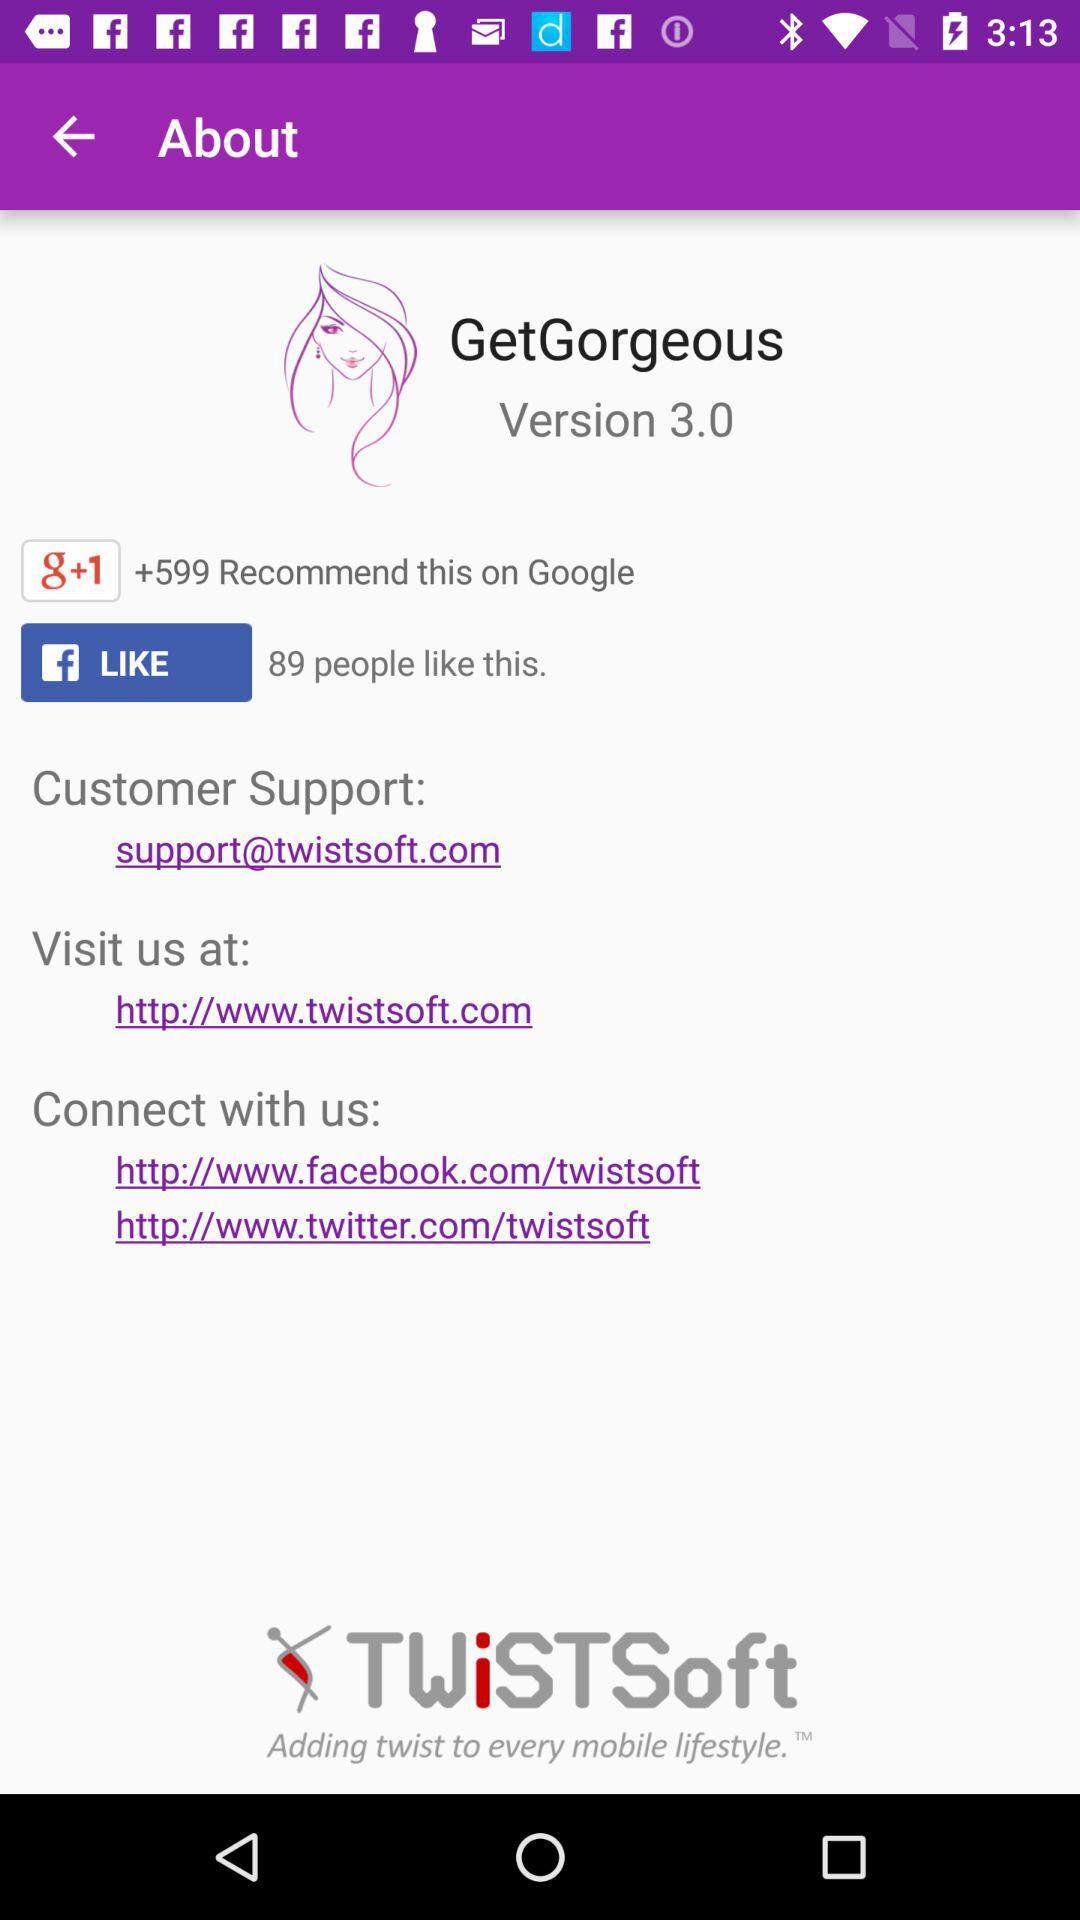What is the version of the application? The version of the application is 3.0. 